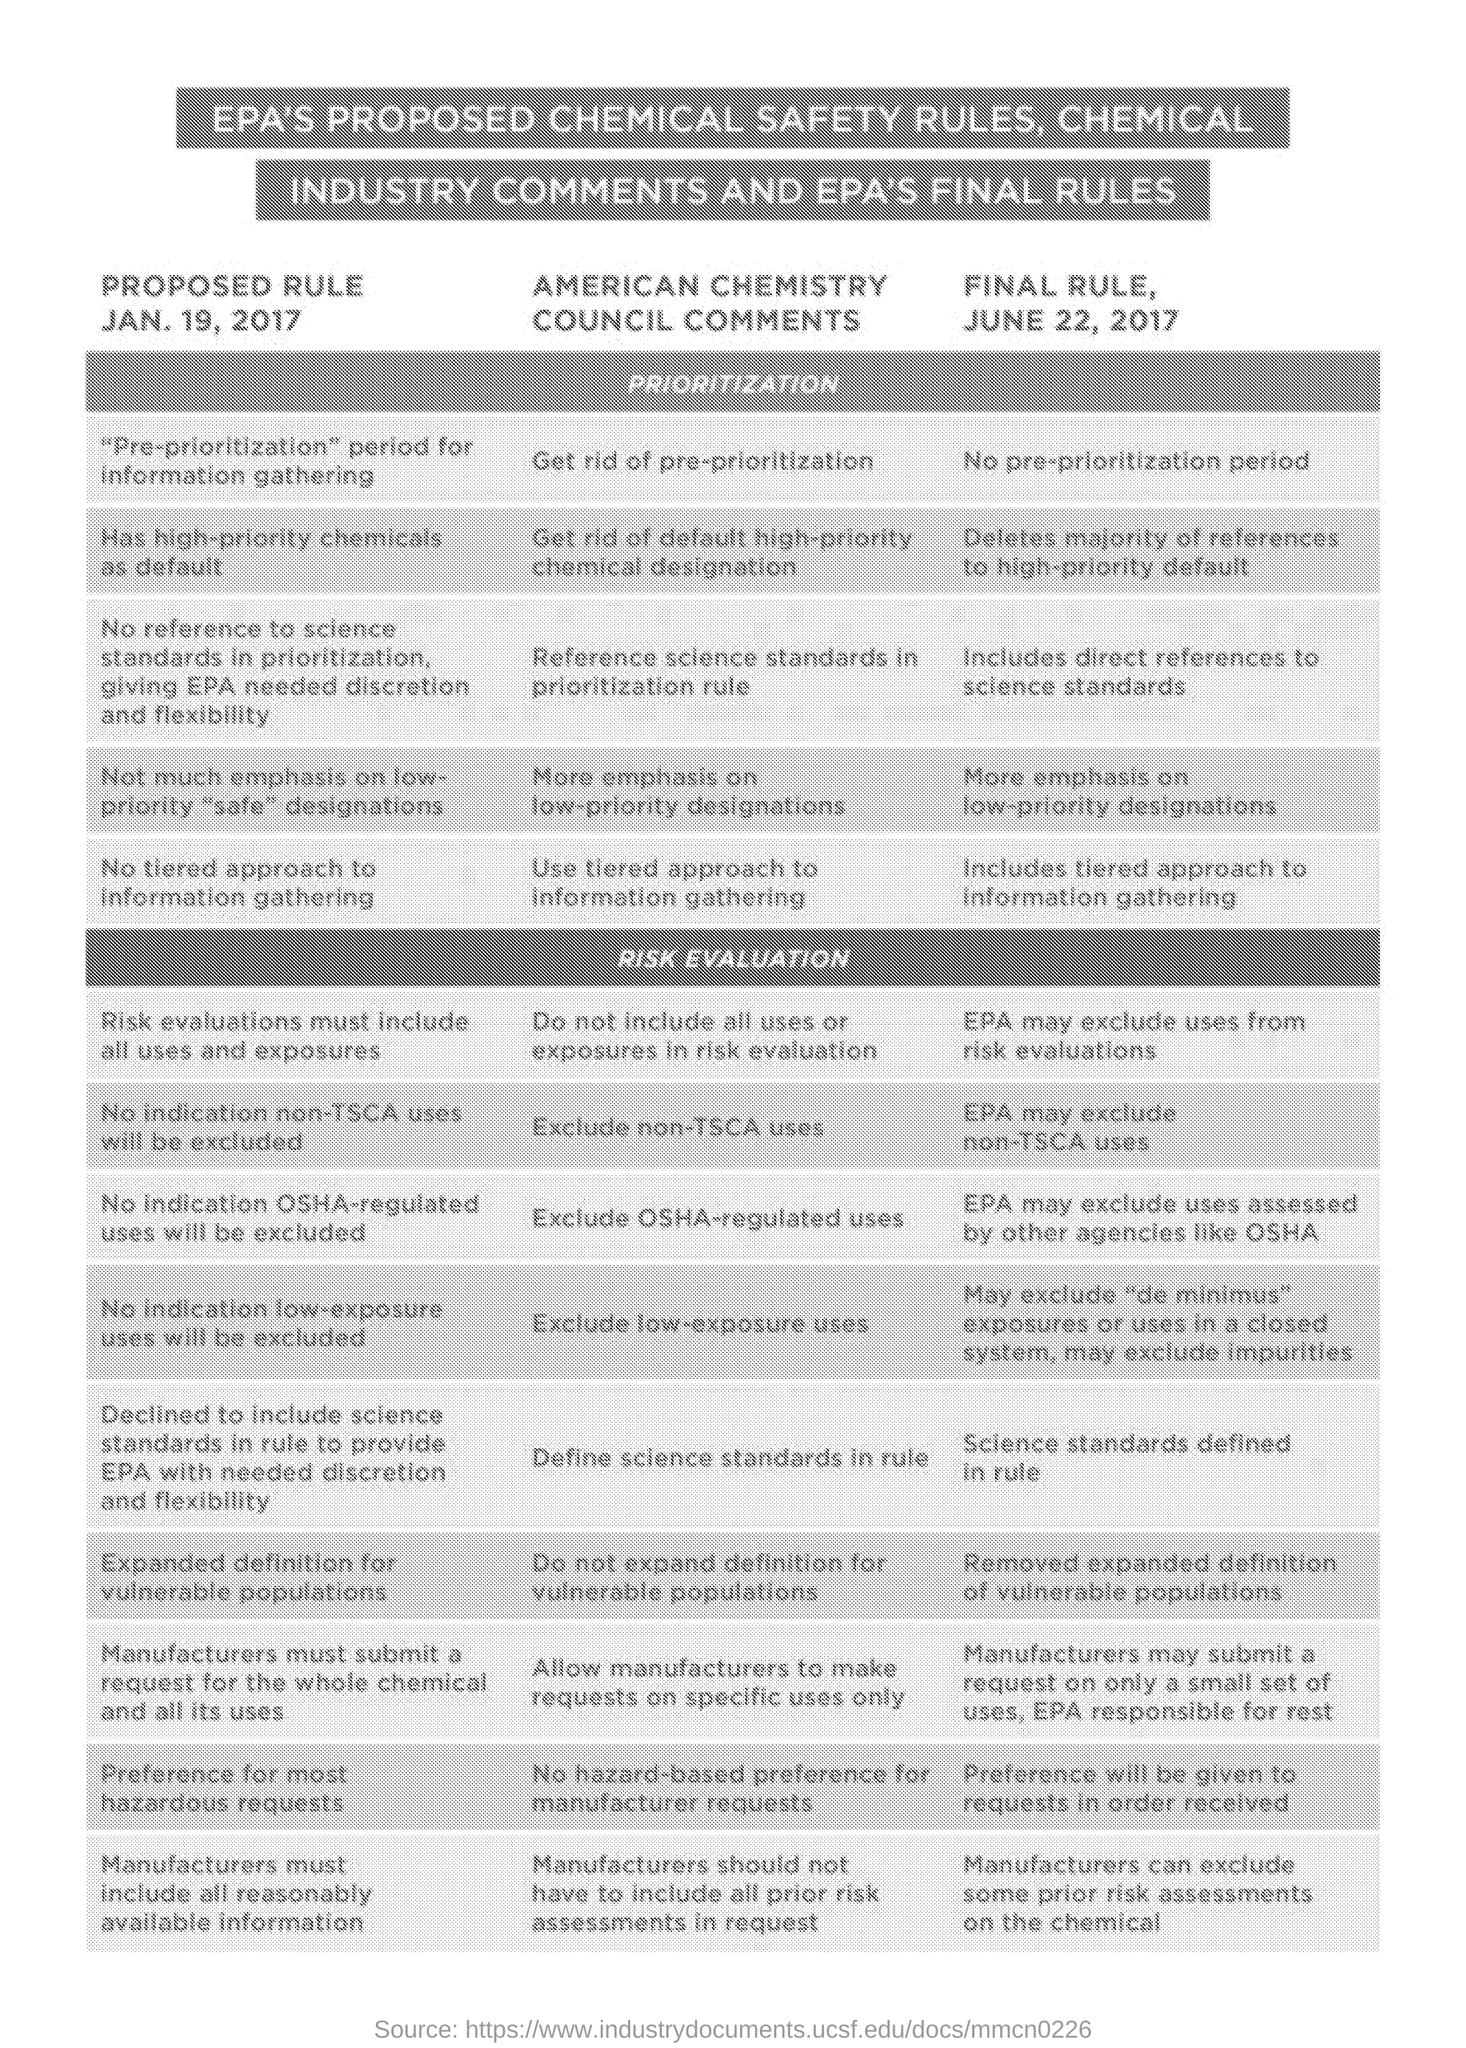When was the rule PROPOSED?
Your response must be concise. Jan. 19, 2017. 